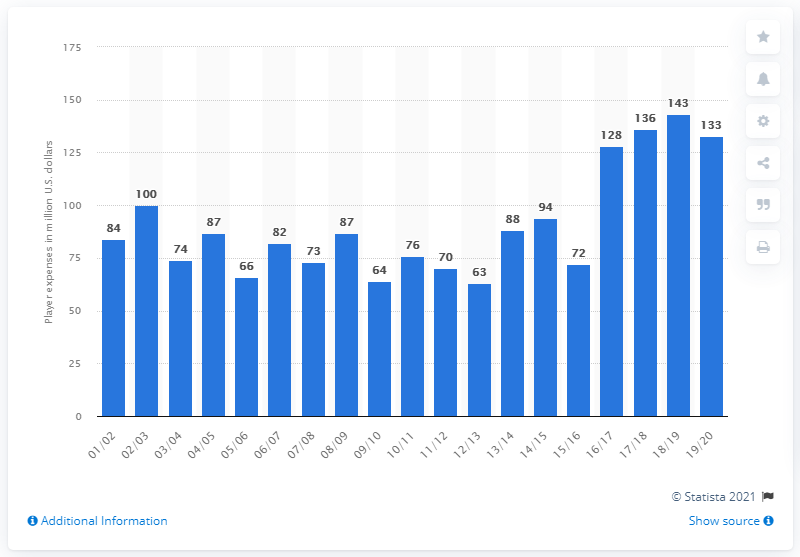Mention a couple of crucial points in this snapshot. The player salaries of the Portland Trail Blazers in the 2019/20 season were approximately 133 million dollars. 